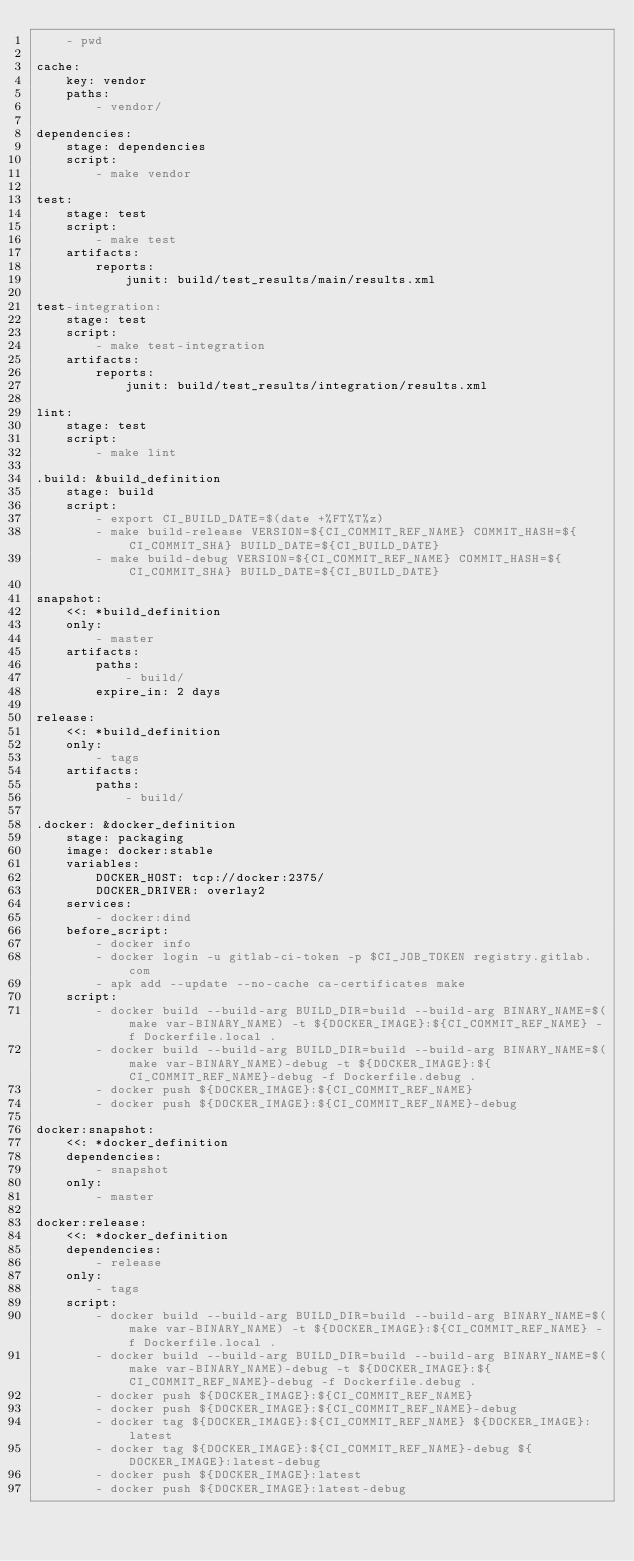<code> <loc_0><loc_0><loc_500><loc_500><_YAML_>    - pwd

cache:
    key: vendor
    paths:
        - vendor/

dependencies:
    stage: dependencies
    script:
        - make vendor

test:
    stage: test
    script:
        - make test
    artifacts:
        reports:
            junit: build/test_results/main/results.xml

test-integration:
    stage: test
    script:
        - make test-integration
    artifacts:
        reports:
            junit: build/test_results/integration/results.xml

lint:
    stage: test
    script:
        - make lint

.build: &build_definition
    stage: build
    script:
        - export CI_BUILD_DATE=$(date +%FT%T%z)
        - make build-release VERSION=${CI_COMMIT_REF_NAME} COMMIT_HASH=${CI_COMMIT_SHA} BUILD_DATE=${CI_BUILD_DATE}
        - make build-debug VERSION=${CI_COMMIT_REF_NAME} COMMIT_HASH=${CI_COMMIT_SHA} BUILD_DATE=${CI_BUILD_DATE}

snapshot:
    <<: *build_definition
    only:
        - master
    artifacts:
        paths:
            - build/
        expire_in: 2 days

release:
    <<: *build_definition
    only:
        - tags
    artifacts:
        paths:
            - build/

.docker: &docker_definition
    stage: packaging
    image: docker:stable
    variables:
        DOCKER_HOST: tcp://docker:2375/
        DOCKER_DRIVER: overlay2
    services:
        - docker:dind
    before_script:
        - docker info
        - docker login -u gitlab-ci-token -p $CI_JOB_TOKEN registry.gitlab.com
        - apk add --update --no-cache ca-certificates make
    script:
        - docker build --build-arg BUILD_DIR=build --build-arg BINARY_NAME=$(make var-BINARY_NAME) -t ${DOCKER_IMAGE}:${CI_COMMIT_REF_NAME} -f Dockerfile.local .
        - docker build --build-arg BUILD_DIR=build --build-arg BINARY_NAME=$(make var-BINARY_NAME)-debug -t ${DOCKER_IMAGE}:${CI_COMMIT_REF_NAME}-debug -f Dockerfile.debug .
        - docker push ${DOCKER_IMAGE}:${CI_COMMIT_REF_NAME}
        - docker push ${DOCKER_IMAGE}:${CI_COMMIT_REF_NAME}-debug

docker:snapshot:
    <<: *docker_definition
    dependencies:
        - snapshot
    only:
        - master

docker:release:
    <<: *docker_definition
    dependencies:
        - release
    only:
        - tags
    script:
        - docker build --build-arg BUILD_DIR=build --build-arg BINARY_NAME=$(make var-BINARY_NAME) -t ${DOCKER_IMAGE}:${CI_COMMIT_REF_NAME} -f Dockerfile.local .
        - docker build --build-arg BUILD_DIR=build --build-arg BINARY_NAME=$(make var-BINARY_NAME)-debug -t ${DOCKER_IMAGE}:${CI_COMMIT_REF_NAME}-debug -f Dockerfile.debug .
        - docker push ${DOCKER_IMAGE}:${CI_COMMIT_REF_NAME}
        - docker push ${DOCKER_IMAGE}:${CI_COMMIT_REF_NAME}-debug
        - docker tag ${DOCKER_IMAGE}:${CI_COMMIT_REF_NAME} ${DOCKER_IMAGE}:latest
        - docker tag ${DOCKER_IMAGE}:${CI_COMMIT_REF_NAME}-debug ${DOCKER_IMAGE}:latest-debug
        - docker push ${DOCKER_IMAGE}:latest
        - docker push ${DOCKER_IMAGE}:latest-debug
</code> 